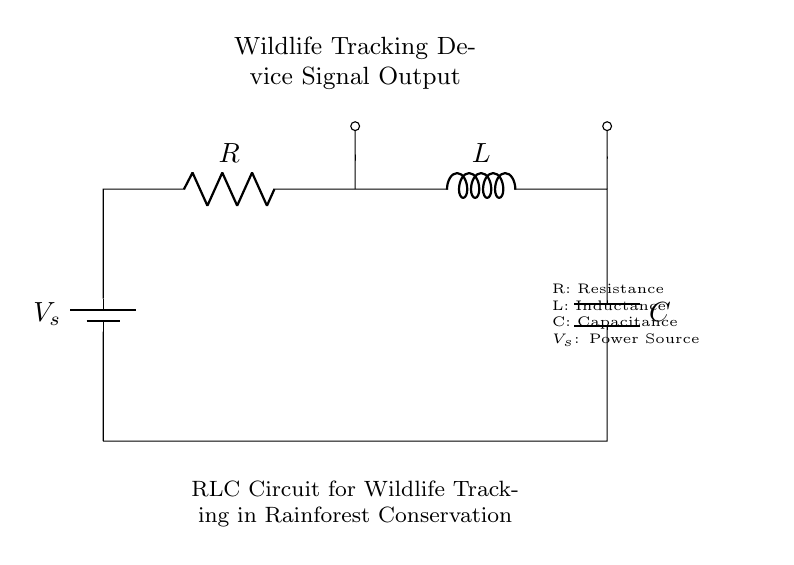What is the power source in this circuit? The power source is represented by the battery symbol labeled V_s, which provides the electrical energy needed for the circuit operation.
Answer: V_s What are the components of this RLC circuit? The components of this RLC circuit include a resistor (R), an inductor (L), and a capacitor (C), all connected in series with the power source V_s.
Answer: R, L, C What does the capacitor do in the circuit? The capacitor stores electrical energy temporarily and helps in smoothing out voltage fluctuations, providing stability to the wildlife tracking device's signal output.
Answer: Stabilizes signal How are the components connected in this circuit? The components are connected in series, meaning the output from each component feeds directly into the next, starting from the power source to the resistor, then to the inductor and lastly to the capacitor before returning to the power source.
Answer: In series What is the function of the inductor in this circuit? The inductor primarily stores energy in a magnetic field when current flows through it, which helps in managing current fluctuations, thus enhancing the reliability of the wildlife tracking signals.
Answer: Stores energy What is the main purpose of this RLC circuit? The main purpose of this RLC circuit is to ensure reliable transmission of signals from wildlife tracking devices, which is crucial for effective rainforest conservation efforts.
Answer: Signal transmission 